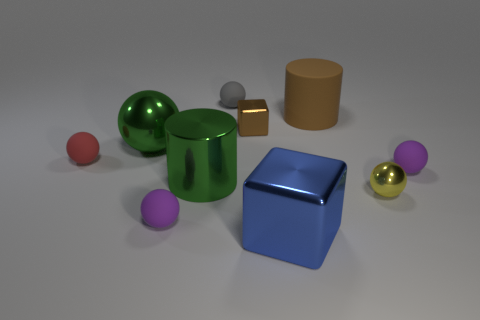Subtract 2 spheres. How many spheres are left? 4 Subtract all gray balls. How many balls are left? 5 Subtract all large balls. How many balls are left? 5 Subtract all red balls. Subtract all green cylinders. How many balls are left? 5 Subtract all balls. How many objects are left? 4 Subtract 1 yellow spheres. How many objects are left? 9 Subtract all large matte cylinders. Subtract all metallic blocks. How many objects are left? 7 Add 4 large green metal spheres. How many large green metal spheres are left? 5 Add 3 brown matte cylinders. How many brown matte cylinders exist? 4 